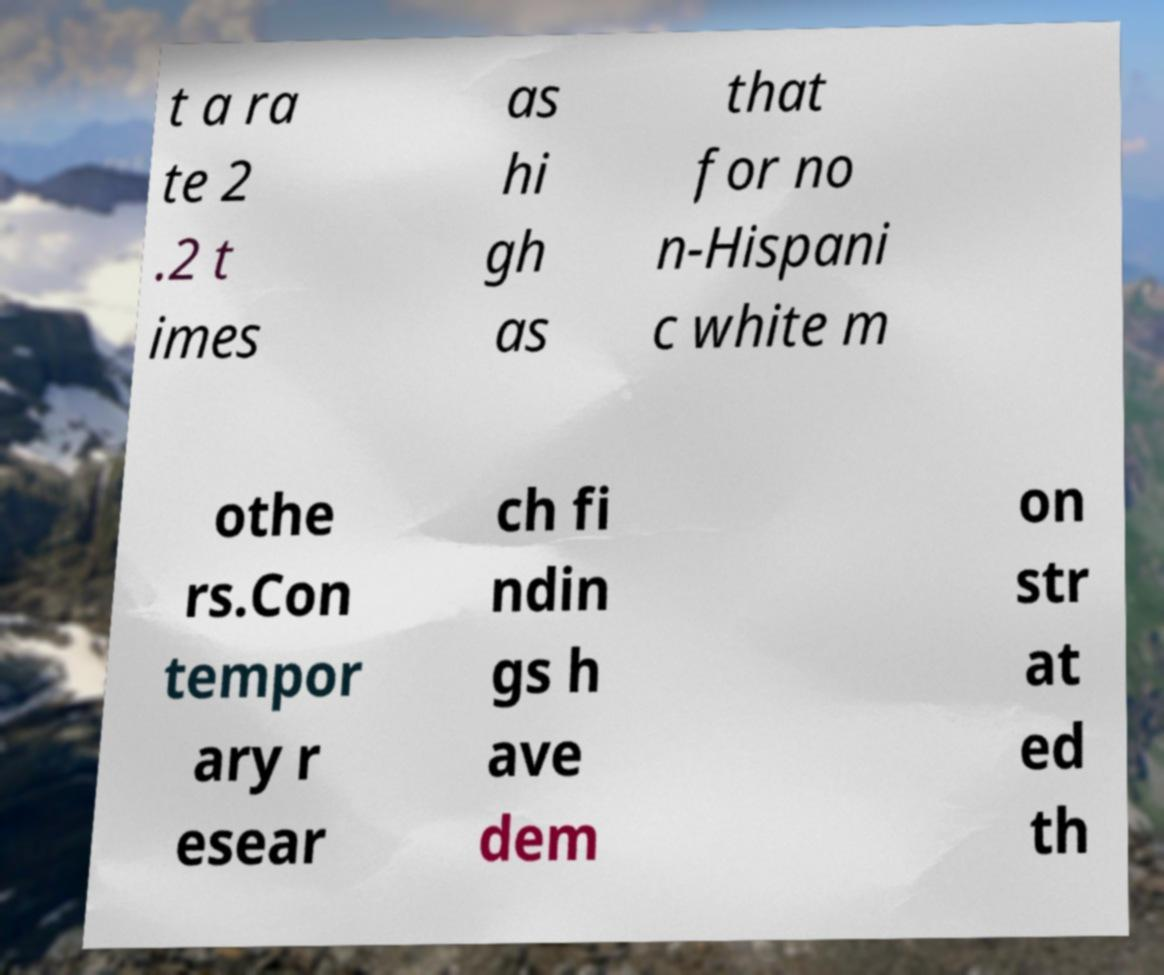Can you accurately transcribe the text from the provided image for me? t a ra te 2 .2 t imes as hi gh as that for no n-Hispani c white m othe rs.Con tempor ary r esear ch fi ndin gs h ave dem on str at ed th 